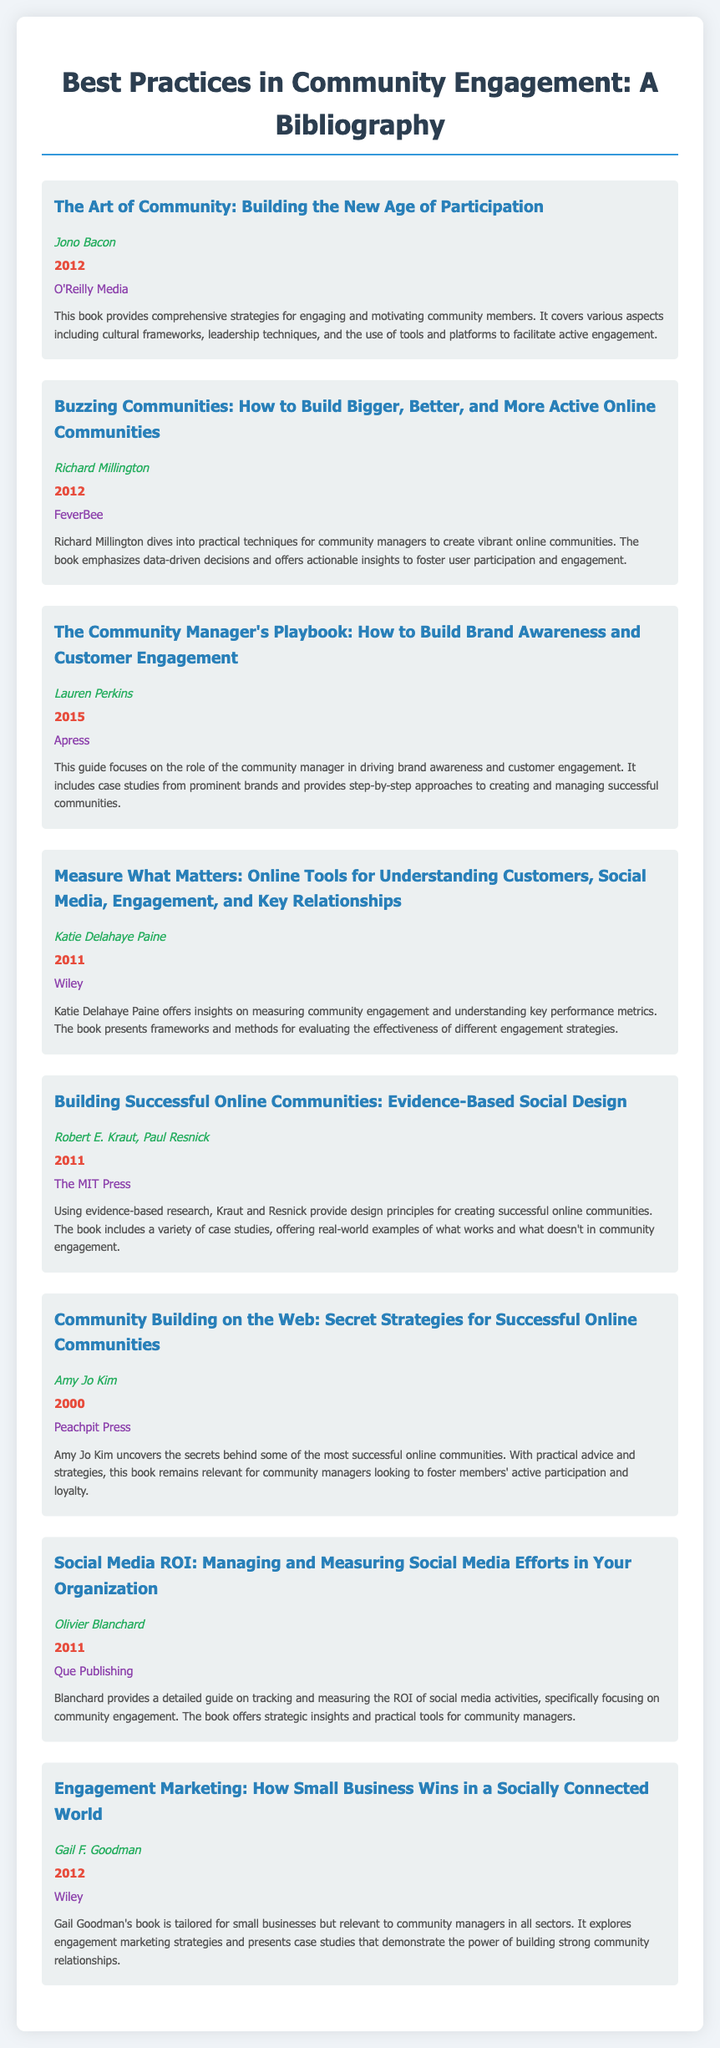What is the title of the first book listed? The first book title appears at the top of the bibliography section, which is "The Art of Community: Building the New Age of Participation."
Answer: The Art of Community: Building the New Age of Participation Who is the author of "Buzzing Communities"? The document contains the author's name beneath the title of the book “Buzzing Communities,” which is Richard Millington.
Answer: Richard Millington What year was "The Community Manager's Playbook" published? The year of publication for "The Community Manager's Playbook" is indicated in the document, which states it was published in 2015.
Answer: 2015 Which publishing company published "Measure What Matters"? The publisher details for "Measure What Matters" are found in the entry, identifying Wiley as the publisher.
Answer: Wiley How many books are listed in the bibliography? The number of books is determined by counting the entries, which total to eight books.
Answer: Eight What is the main focus of the book "Community Building on the Web"? The description for "Community Building on the Web" outlines it focuses on uncovering the secrets behind successful online communities.
Answer: Successful online communities What type of strategies does "Engagement Marketing" discuss? The description for "Engagement Marketing" highlights it discusses engagement marketing strategies for small businesses and community managers.
Answer: Engagement marketing strategies What is the key theme present in "Building Successful Online Communities"? The document describes it as being based on evidence-based research and design principles for online communities.
Answer: Evidence-based research 